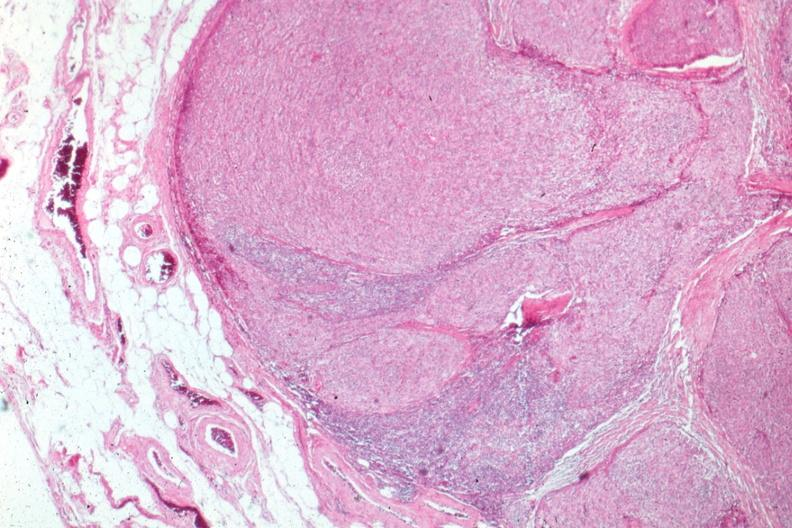s thymus present?
Answer the question using a single word or phrase. Yes 